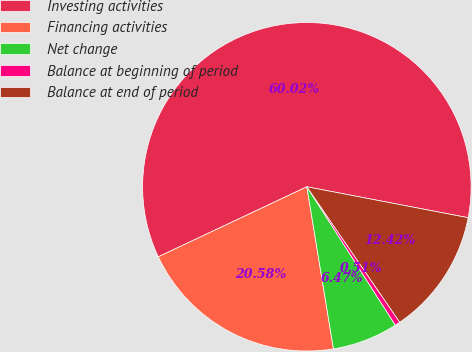Convert chart. <chart><loc_0><loc_0><loc_500><loc_500><pie_chart><fcel>Investing activities<fcel>Financing activities<fcel>Net change<fcel>Balance at beginning of period<fcel>Balance at end of period<nl><fcel>60.03%<fcel>20.58%<fcel>6.47%<fcel>0.51%<fcel>12.42%<nl></chart> 